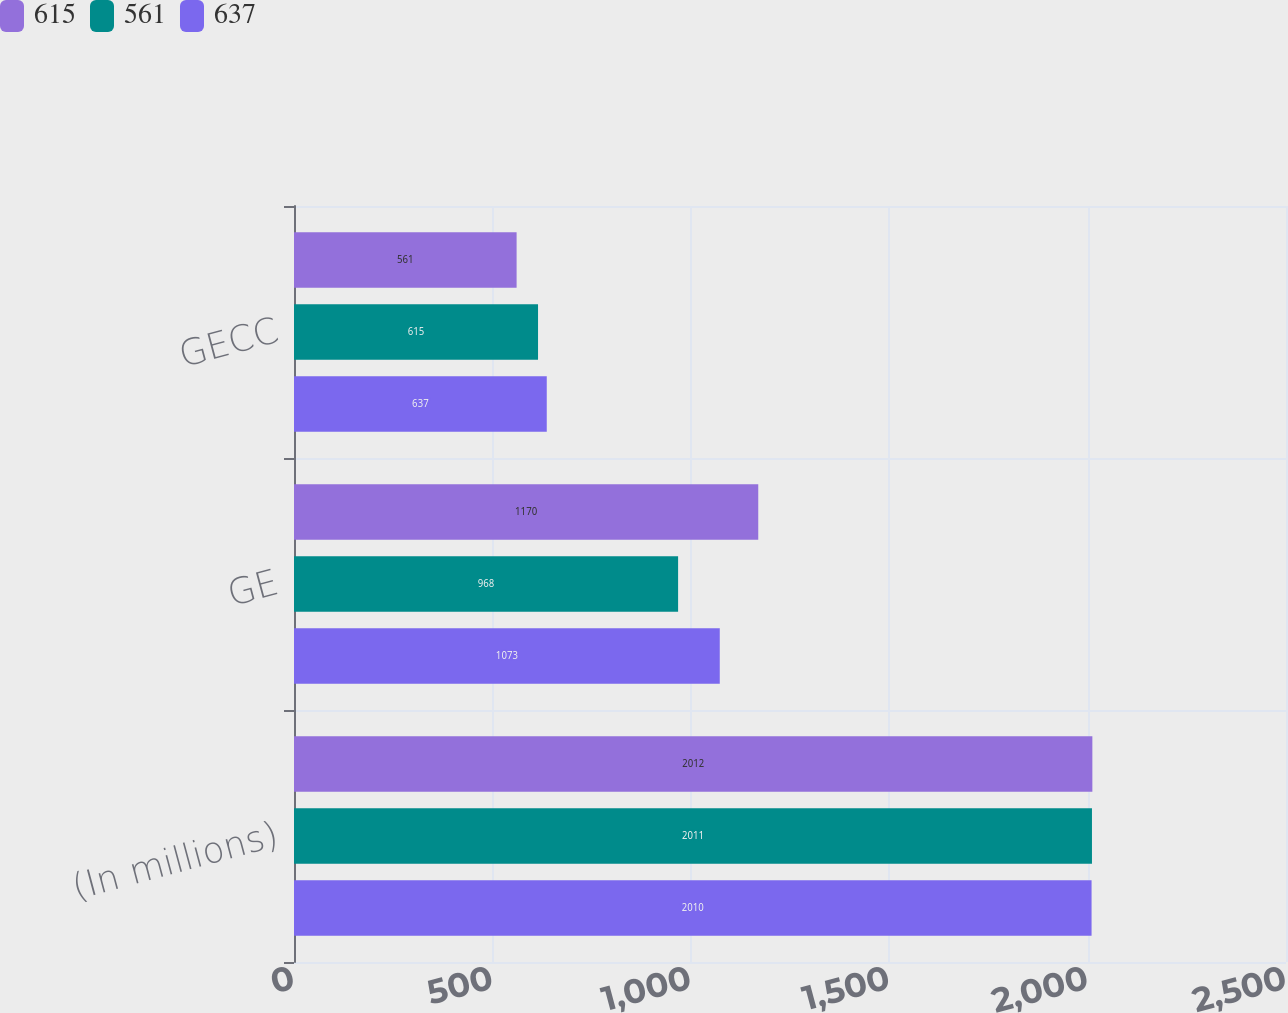Convert chart to OTSL. <chart><loc_0><loc_0><loc_500><loc_500><stacked_bar_chart><ecel><fcel>(In millions)<fcel>GE<fcel>GECC<nl><fcel>615<fcel>2012<fcel>1170<fcel>561<nl><fcel>561<fcel>2011<fcel>968<fcel>615<nl><fcel>637<fcel>2010<fcel>1073<fcel>637<nl></chart> 